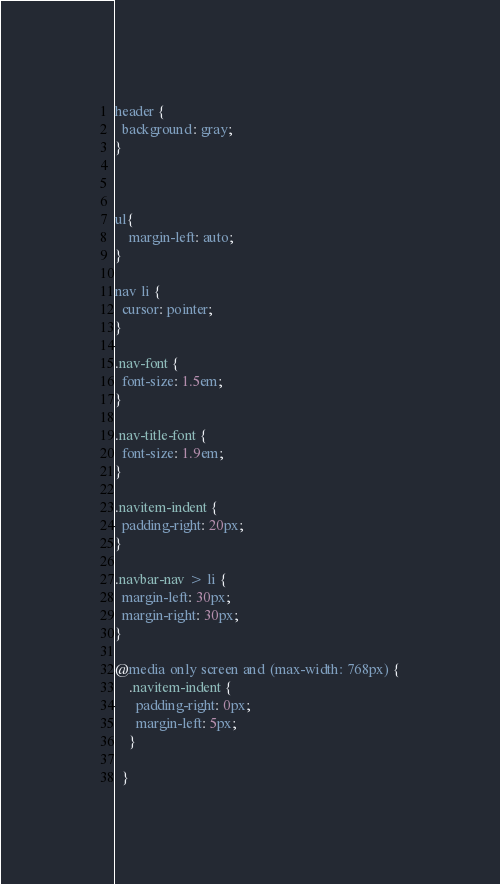<code> <loc_0><loc_0><loc_500><loc_500><_CSS_>header {
  background: gray;
}



ul{
    margin-left: auto;
}

nav li {
  cursor: pointer;
}

.nav-font {
  font-size: 1.5em;
}

.nav-title-font {
  font-size: 1.9em;
}

.navitem-indent {
  padding-right: 20px;
}

.navbar-nav > li {
  margin-left: 30px;
  margin-right: 30px;
}

@media only screen and (max-width: 768px) {
    .navitem-indent {
      padding-right: 0px;
      margin-left: 5px;
    }
    
  }</code> 